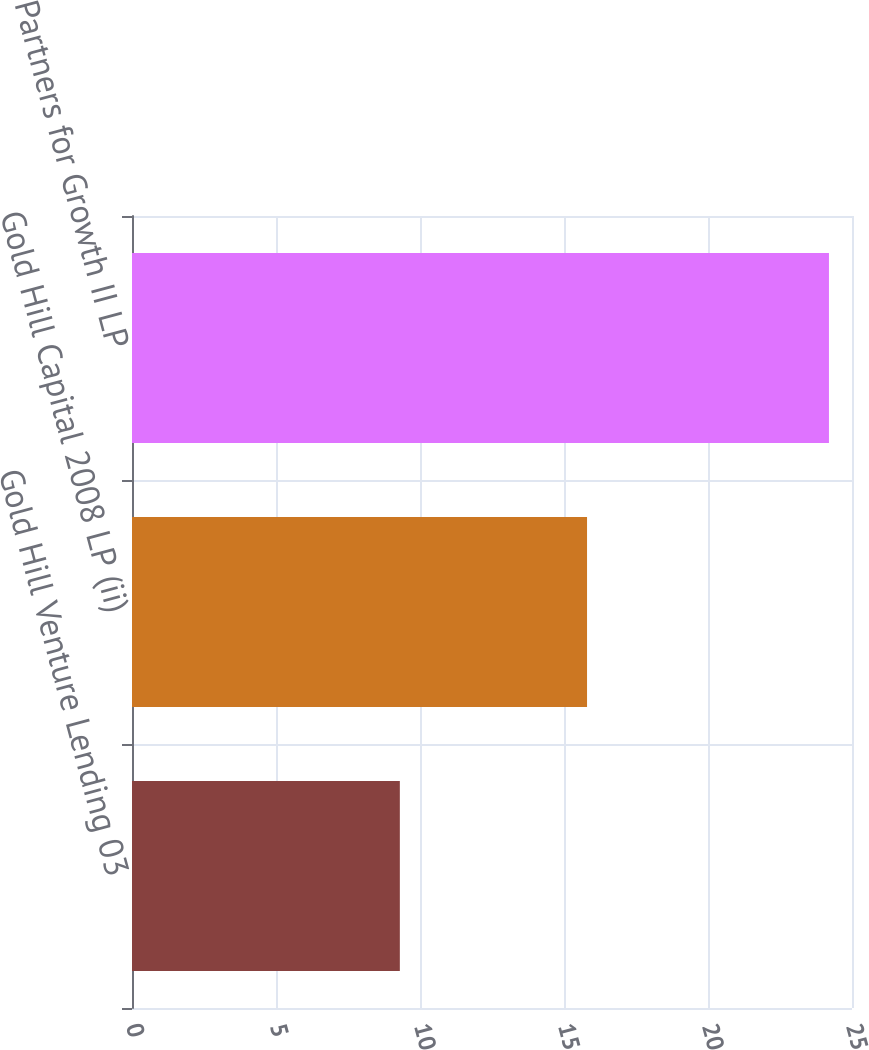Convert chart to OTSL. <chart><loc_0><loc_0><loc_500><loc_500><bar_chart><fcel>Gold Hill Venture Lending 03<fcel>Gold Hill Capital 2008 LP (ii)<fcel>Partners for Growth II LP<nl><fcel>9.3<fcel>15.8<fcel>24.2<nl></chart> 